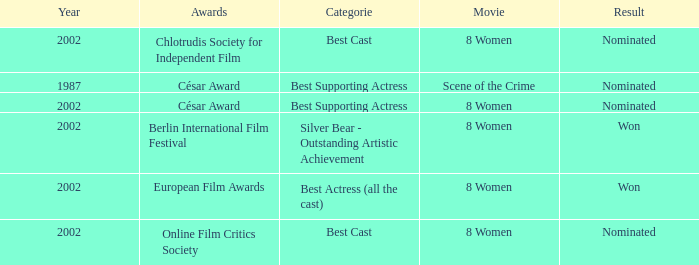What was the categorie in 2002 at the Berlin international Film Festival that Danielle Darrieux was in? Silver Bear - Outstanding Artistic Achievement. 